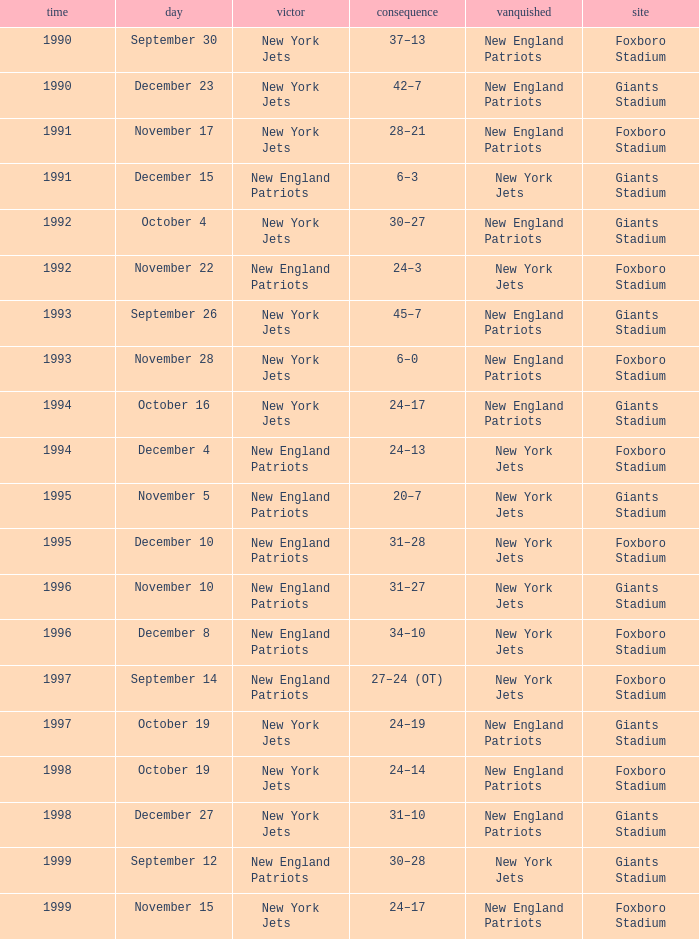What is the year when the Winner was the new york jets, with a Result of 24–17, played at giants stadium? 1994.0. 